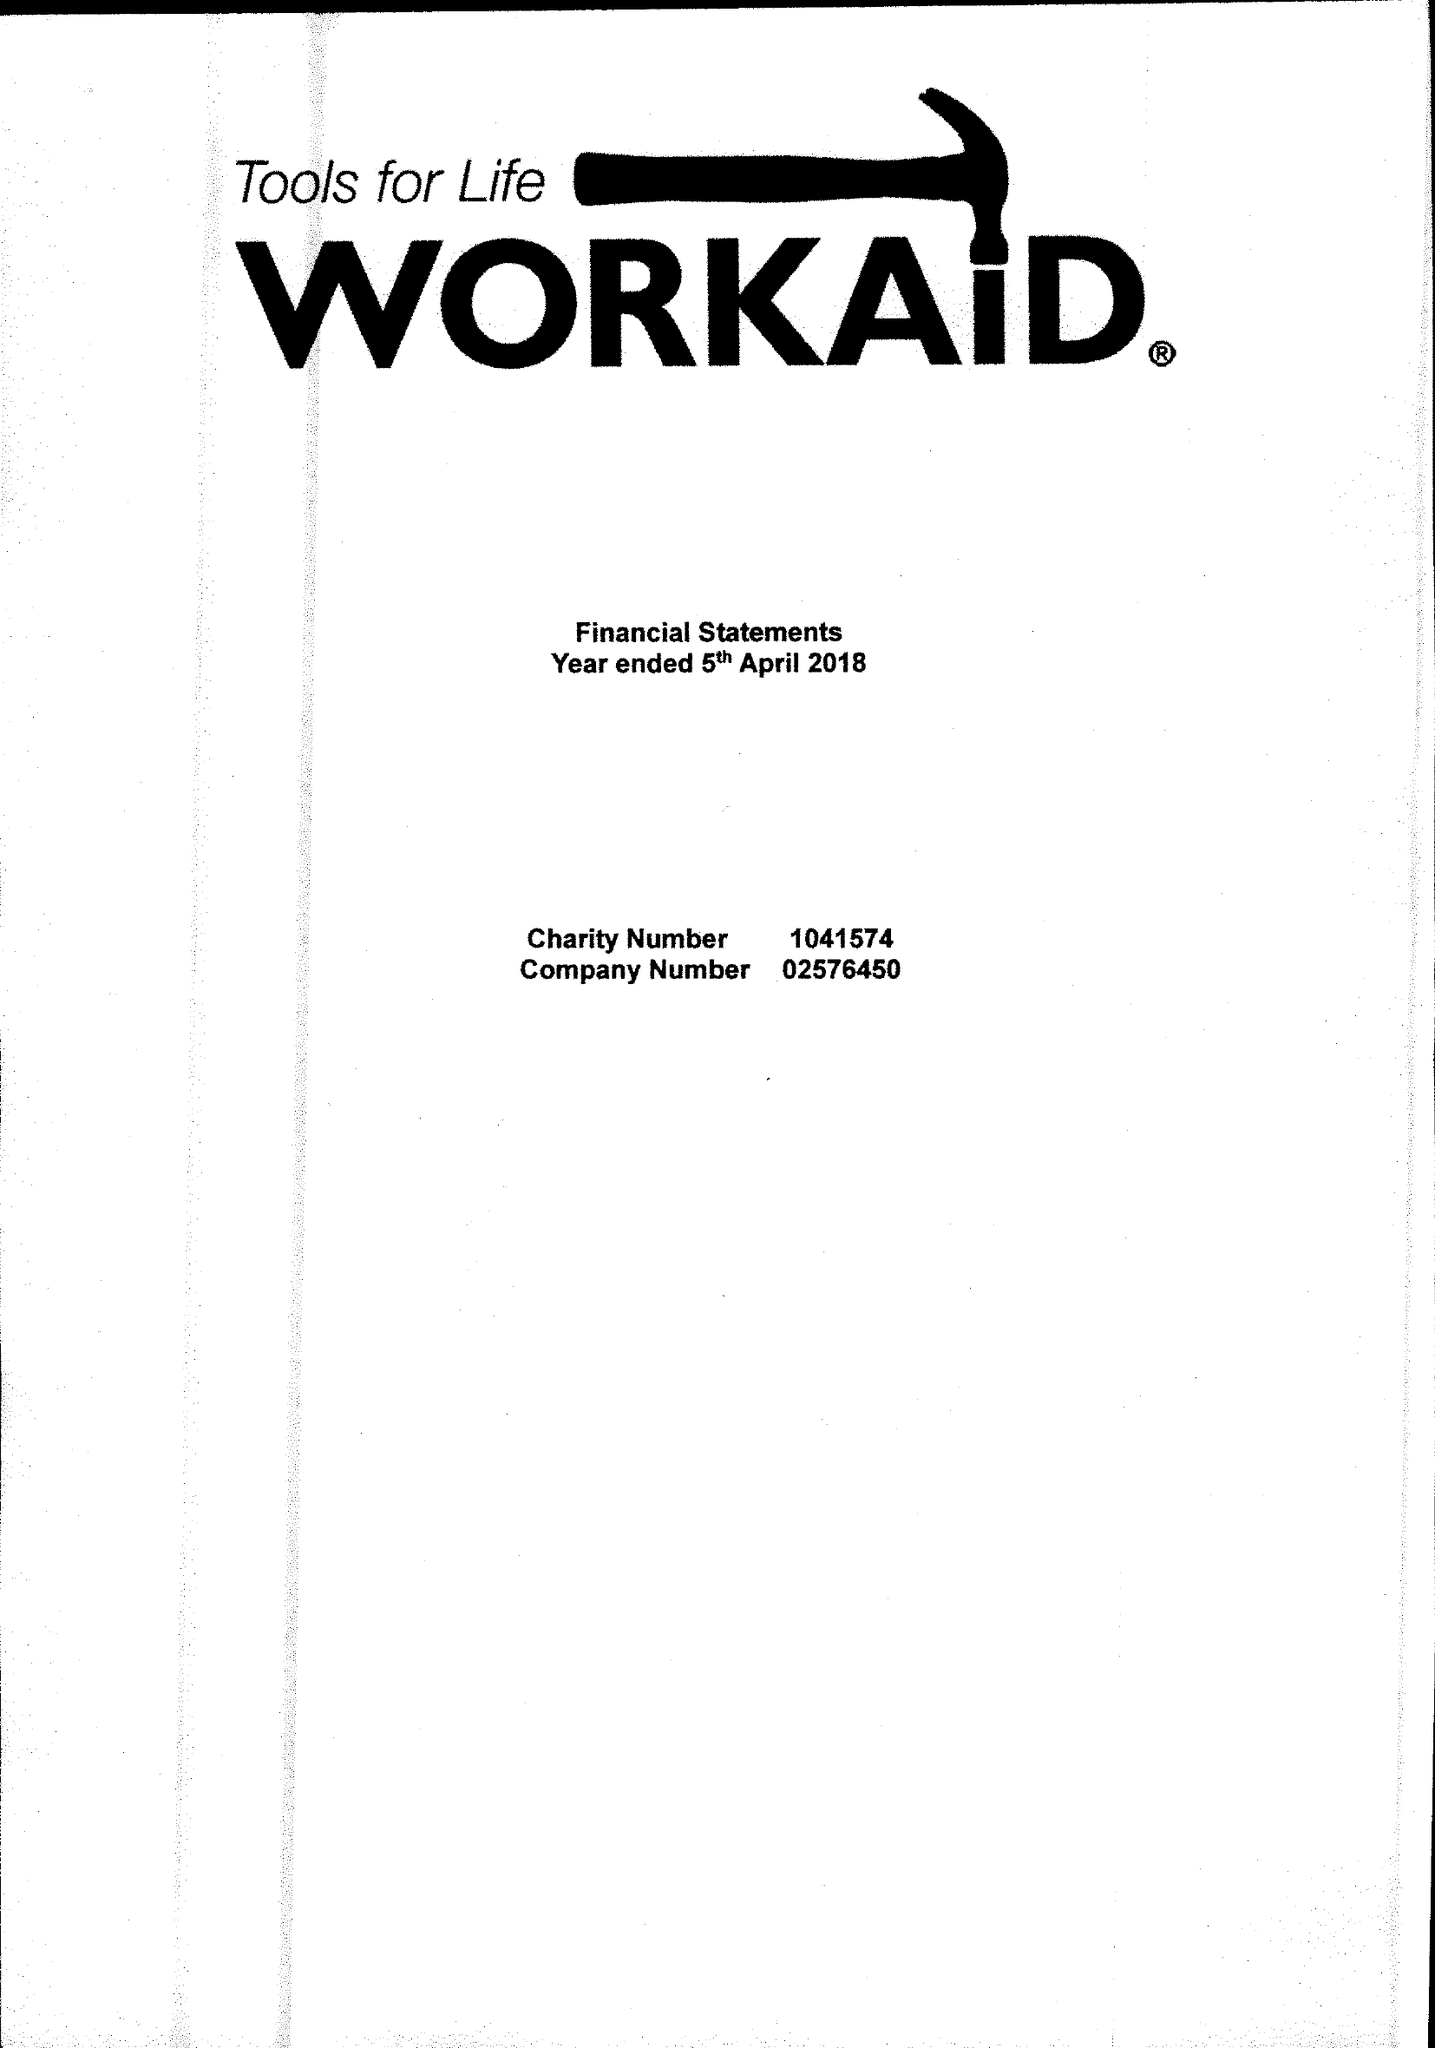What is the value for the report_date?
Answer the question using a single word or phrase. 2018-04-05 